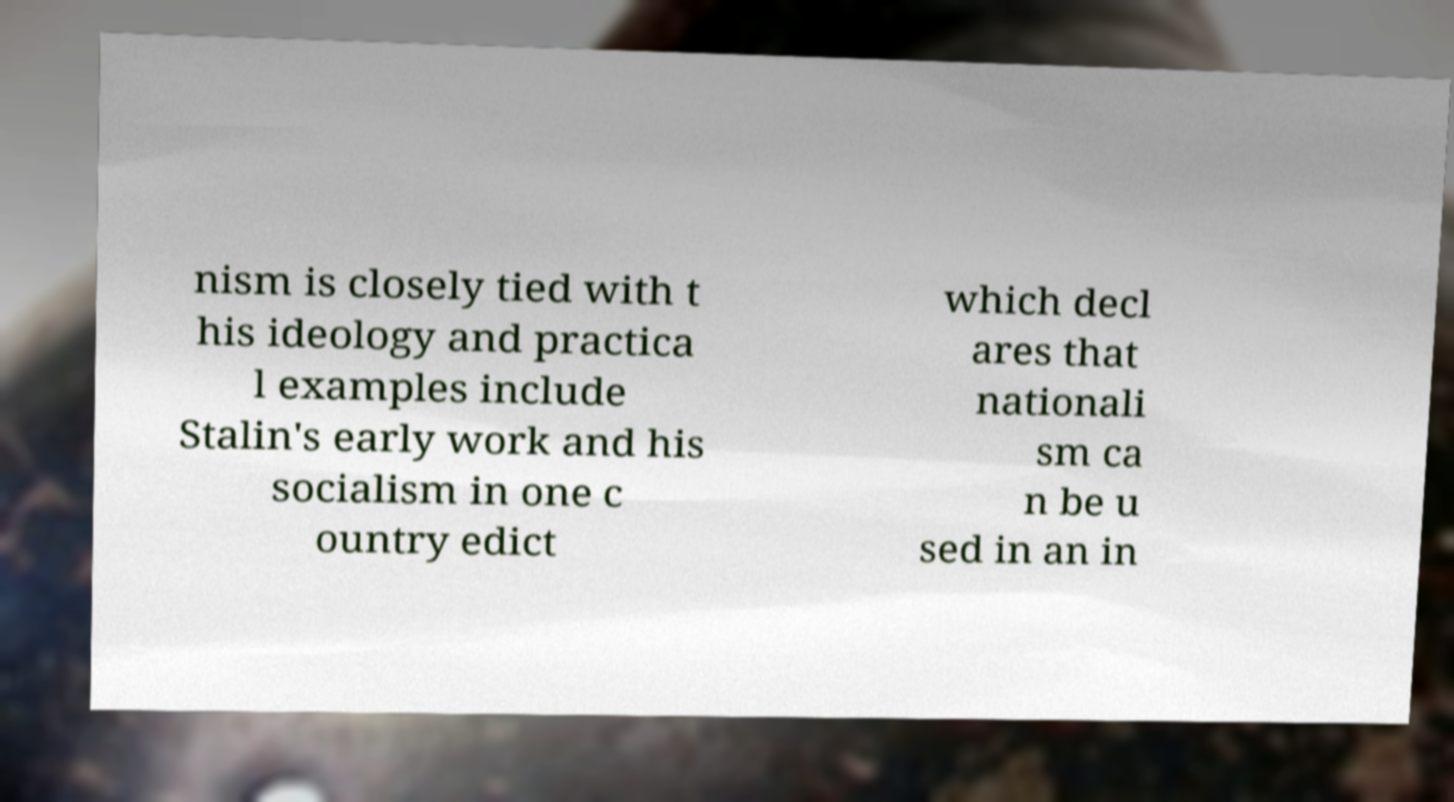I need the written content from this picture converted into text. Can you do that? nism is closely tied with t his ideology and practica l examples include Stalin's early work and his socialism in one c ountry edict which decl ares that nationali sm ca n be u sed in an in 